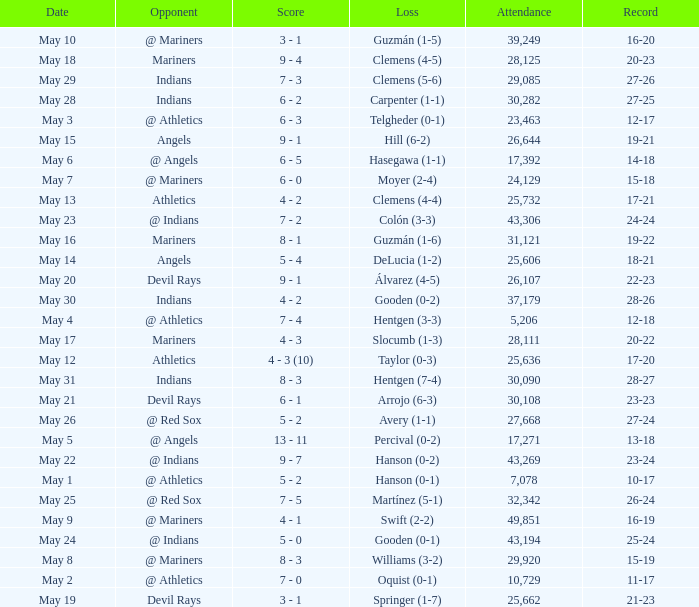When the record is 16-20 and attendance is greater than 32,342, what is the score? 3 - 1. 